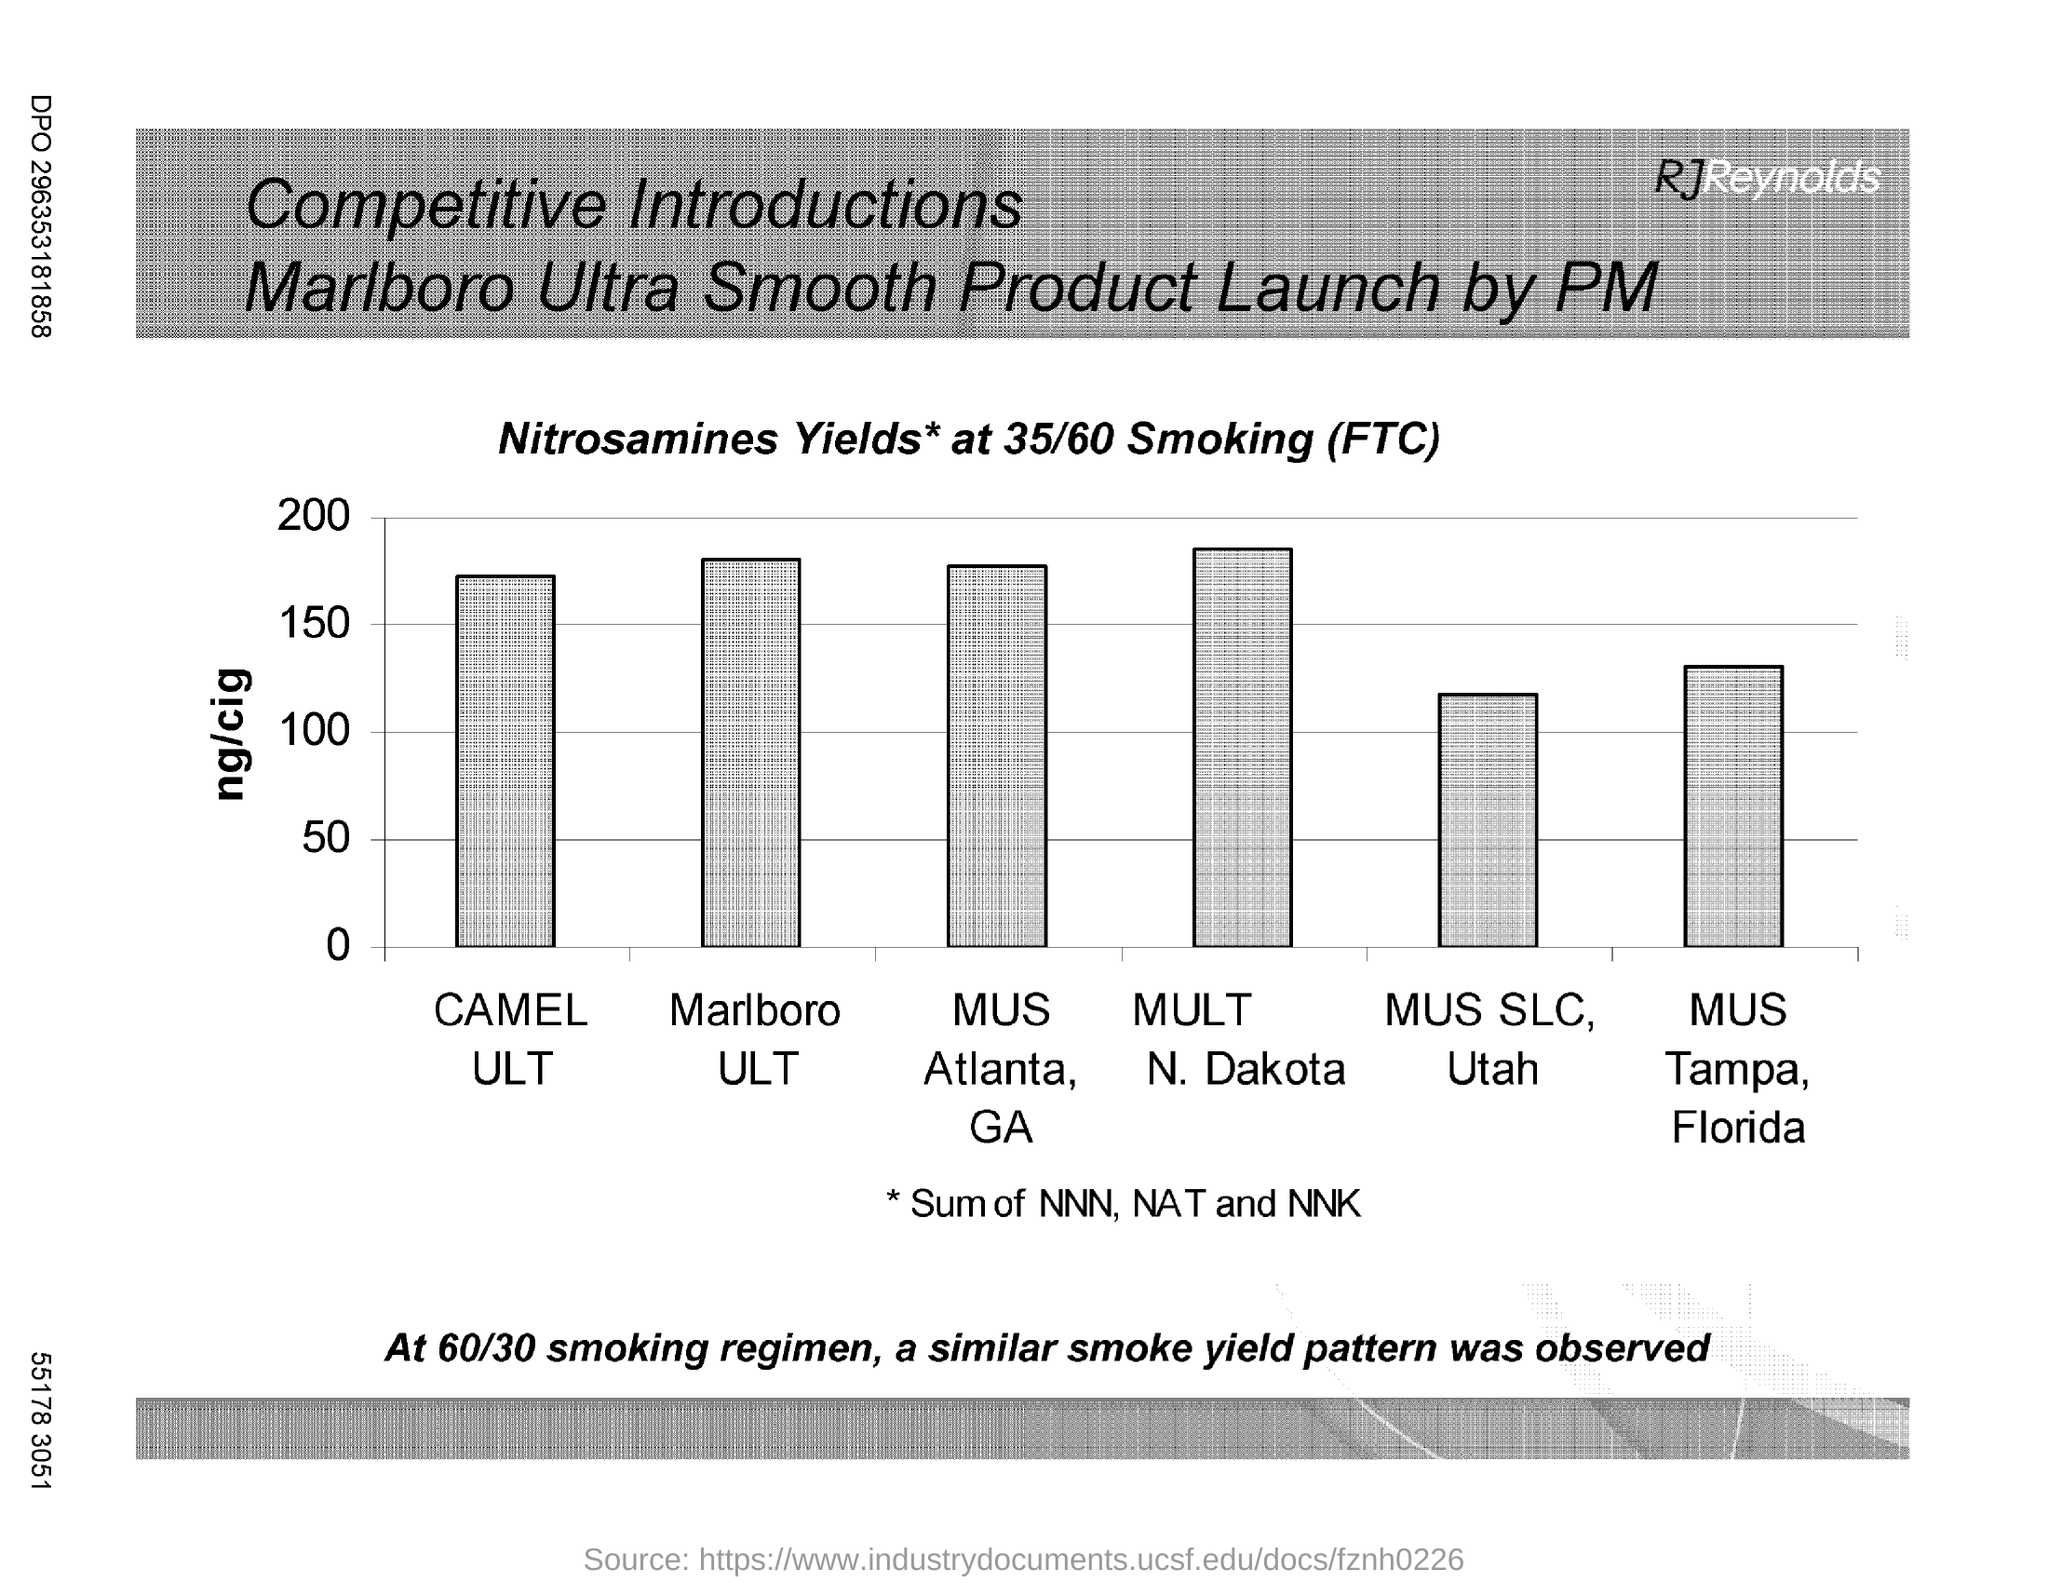List a handful of essential elements in this visual. The product with the highest nicotine content per cigarette is MULT N. DAKOTA. 